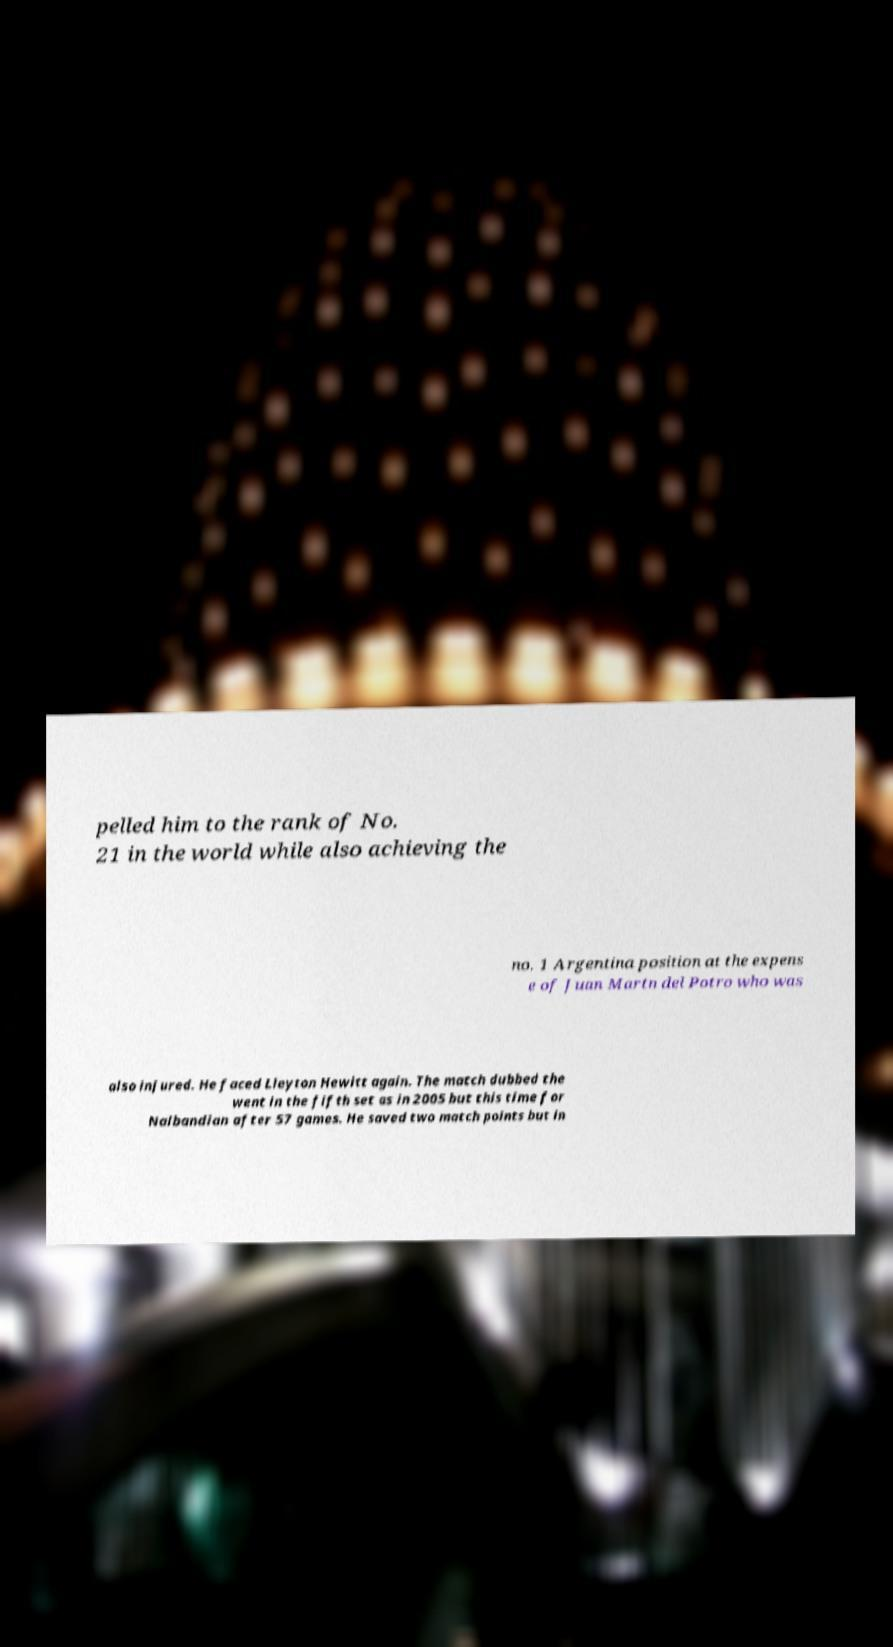Can you accurately transcribe the text from the provided image for me? pelled him to the rank of No. 21 in the world while also achieving the no. 1 Argentina position at the expens e of Juan Martn del Potro who was also injured. He faced Lleyton Hewitt again. The match dubbed the went in the fifth set as in 2005 but this time for Nalbandian after 57 games. He saved two match points but in 